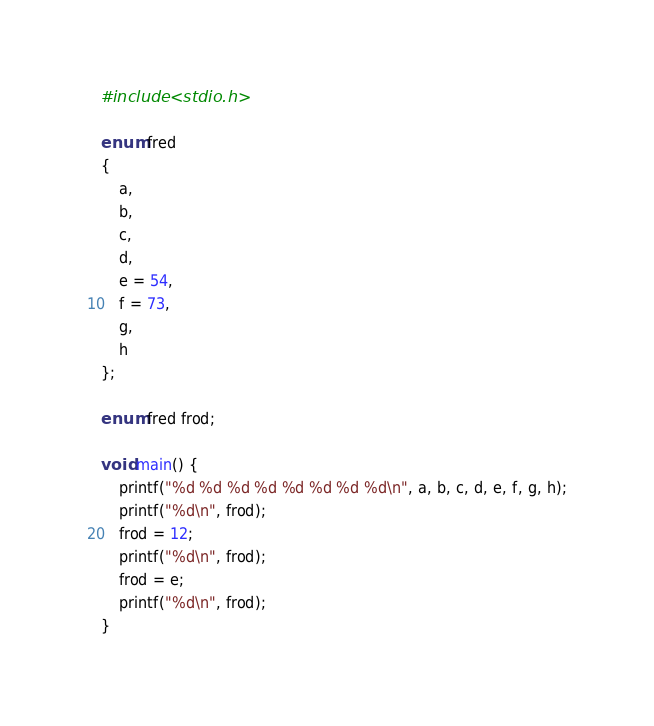<code> <loc_0><loc_0><loc_500><loc_500><_C_>#include <stdio.h>

enum fred
{
    a,
    b,
    c,
    d,
    e = 54,
    f = 73,
    g,
    h
};

enum fred frod;

void main() {
    printf("%d %d %d %d %d %d %d %d\n", a, b, c, d, e, f, g, h);
    printf("%d\n", frod);
    frod = 12;
    printf("%d\n", frod);
    frod = e;
    printf("%d\n", frod);
}
</code> 